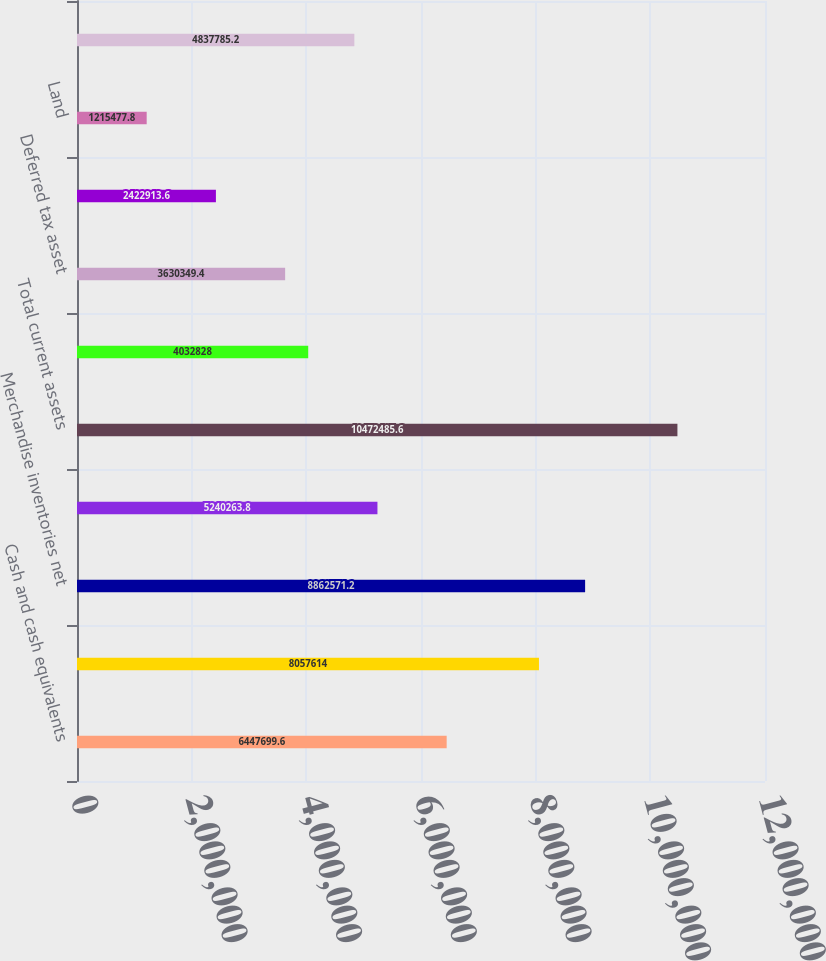<chart> <loc_0><loc_0><loc_500><loc_500><bar_chart><fcel>Cash and cash equivalents<fcel>Trade accounts receivable net<fcel>Merchandise inventories net<fcel>Prepaid expenses and other<fcel>Total current assets<fcel>Goodwill and other intangible<fcel>Deferred tax asset<fcel>Other assets<fcel>Land<fcel>Buildings less allowance for<nl><fcel>6.4477e+06<fcel>8.05761e+06<fcel>8.86257e+06<fcel>5.24026e+06<fcel>1.04725e+07<fcel>4.03283e+06<fcel>3.63035e+06<fcel>2.42291e+06<fcel>1.21548e+06<fcel>4.83779e+06<nl></chart> 